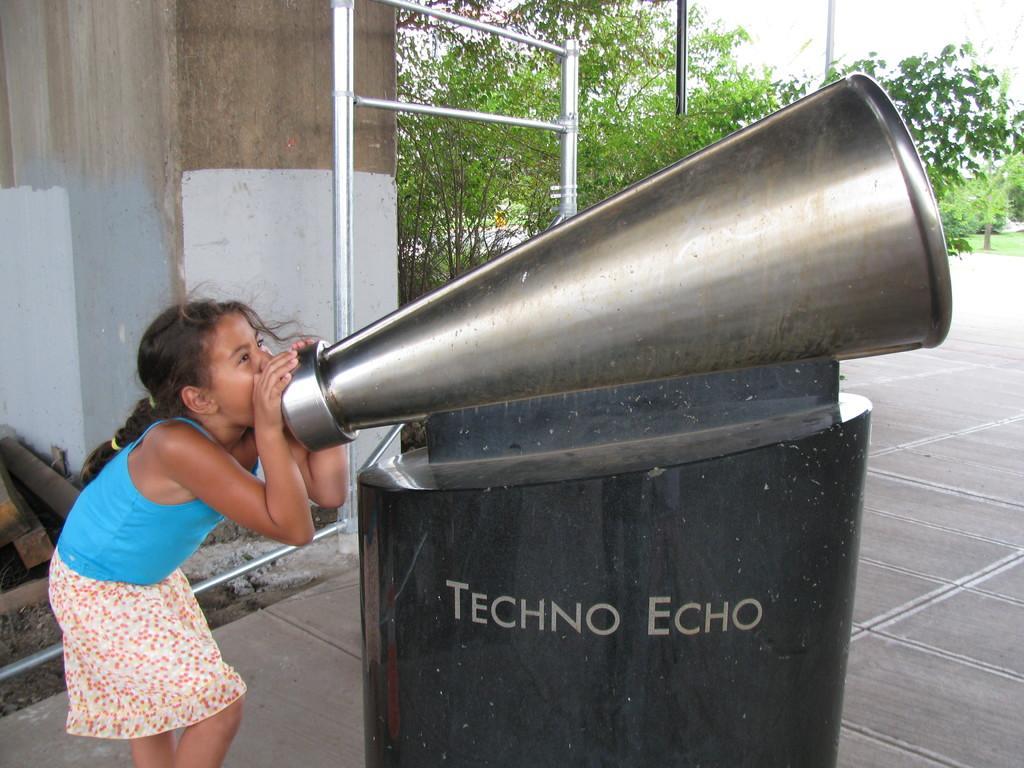In one or two sentences, can you explain what this image depicts? In this image I can see the person standing and the person is wearing blue and white color dress. In front I can see some object in black and silver color. In the background I can see few poles, plants in green color and the sky is in white color. 